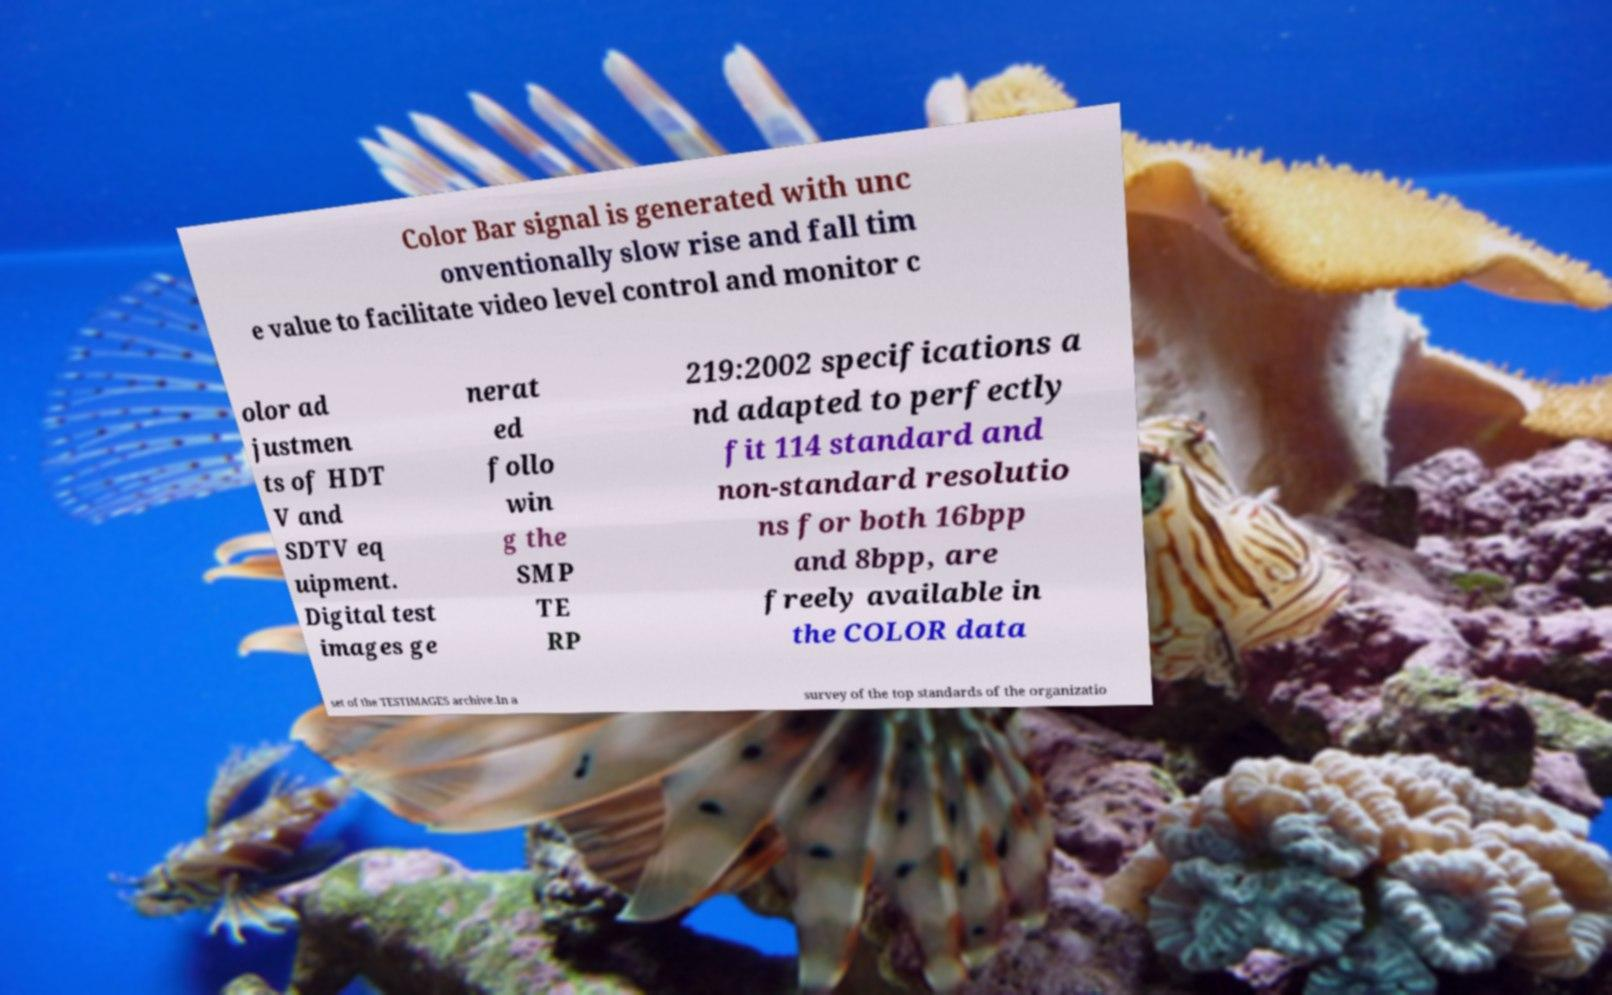Can you accurately transcribe the text from the provided image for me? Color Bar signal is generated with unc onventionally slow rise and fall tim e value to facilitate video level control and monitor c olor ad justmen ts of HDT V and SDTV eq uipment. Digital test images ge nerat ed follo win g the SMP TE RP 219:2002 specifications a nd adapted to perfectly fit 114 standard and non-standard resolutio ns for both 16bpp and 8bpp, are freely available in the COLOR data set of the TESTIMAGES archive.In a survey of the top standards of the organizatio 